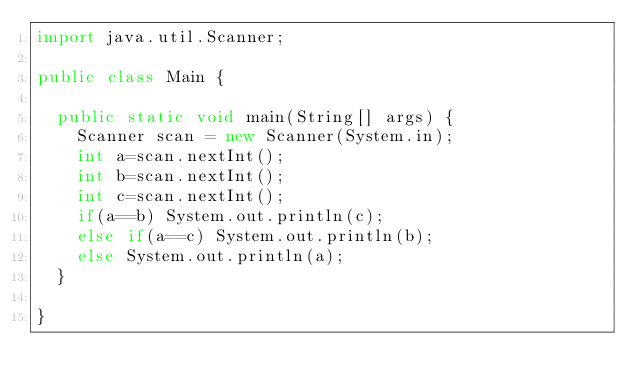Convert code to text. <code><loc_0><loc_0><loc_500><loc_500><_Java_>import java.util.Scanner;

public class Main {

	public static void main(String[] args) {
		Scanner scan = new Scanner(System.in);
		int a=scan.nextInt();
		int b=scan.nextInt();
		int c=scan.nextInt();
		if(a==b) System.out.println(c);
		else if(a==c) System.out.println(b);
		else System.out.println(a);
	}

}
</code> 